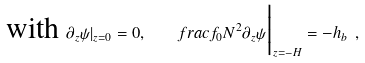<formula> <loc_0><loc_0><loc_500><loc_500>\text {with } \partial _ { z } \psi | _ { z = 0 } = 0 , \quad f r a c { f _ { 0 } } { N ^ { 2 } } \partial _ { z } \psi \Big | _ { z = - H } = - h _ { b } \ ,</formula> 